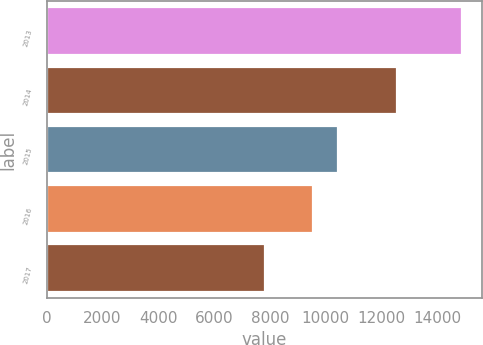Convert chart to OTSL. <chart><loc_0><loc_0><loc_500><loc_500><bar_chart><fcel>2013<fcel>2014<fcel>2015<fcel>2016<fcel>2017<nl><fcel>14862<fcel>12547<fcel>10429<fcel>9532<fcel>7814<nl></chart> 